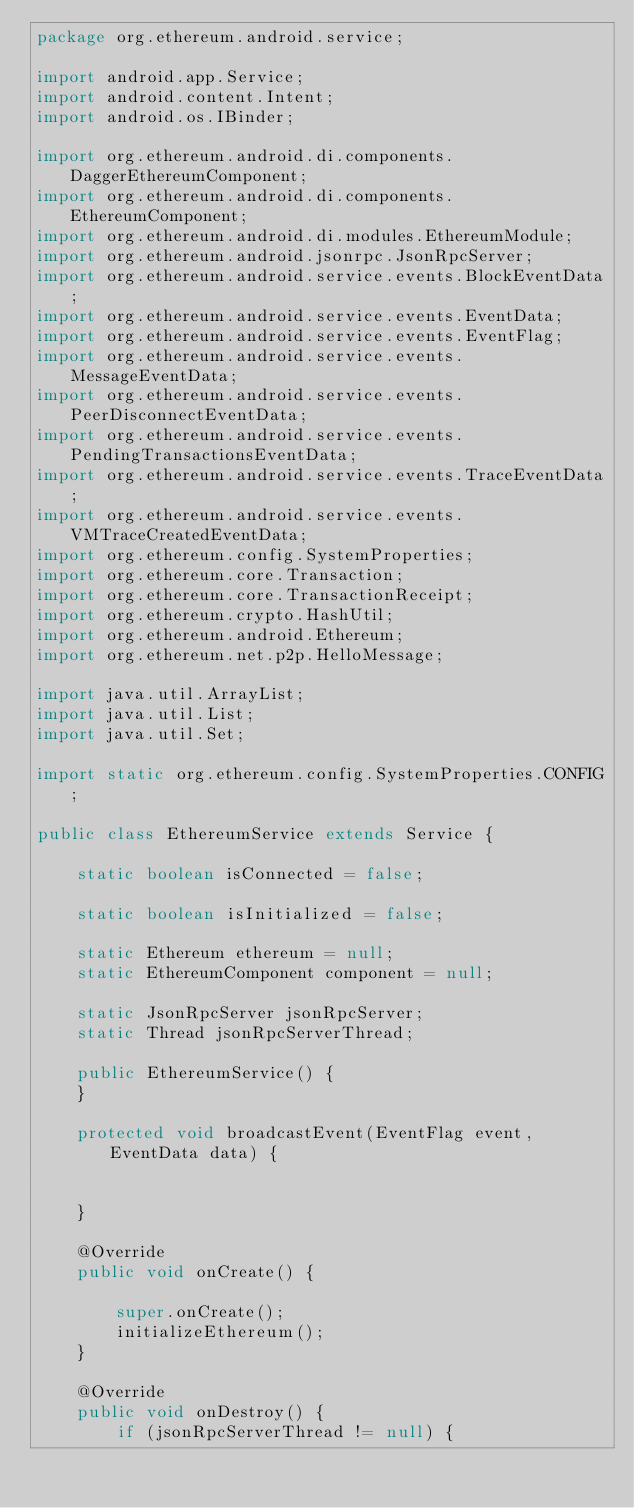Convert code to text. <code><loc_0><loc_0><loc_500><loc_500><_Java_>package org.ethereum.android.service;

import android.app.Service;
import android.content.Intent;
import android.os.IBinder;

import org.ethereum.android.di.components.DaggerEthereumComponent;
import org.ethereum.android.di.components.EthereumComponent;
import org.ethereum.android.di.modules.EthereumModule;
import org.ethereum.android.jsonrpc.JsonRpcServer;
import org.ethereum.android.service.events.BlockEventData;
import org.ethereum.android.service.events.EventData;
import org.ethereum.android.service.events.EventFlag;
import org.ethereum.android.service.events.MessageEventData;
import org.ethereum.android.service.events.PeerDisconnectEventData;
import org.ethereum.android.service.events.PendingTransactionsEventData;
import org.ethereum.android.service.events.TraceEventData;
import org.ethereum.android.service.events.VMTraceCreatedEventData;
import org.ethereum.config.SystemProperties;
import org.ethereum.core.Transaction;
import org.ethereum.core.TransactionReceipt;
import org.ethereum.crypto.HashUtil;
import org.ethereum.android.Ethereum;
import org.ethereum.net.p2p.HelloMessage;

import java.util.ArrayList;
import java.util.List;
import java.util.Set;

import static org.ethereum.config.SystemProperties.CONFIG;

public class EthereumService extends Service {

    static boolean isConnected = false;

    static boolean isInitialized = false;

    static Ethereum ethereum = null;
    static EthereumComponent component = null;

    static JsonRpcServer jsonRpcServer;
    static Thread jsonRpcServerThread;

    public EthereumService() {
    }

    protected void broadcastEvent(EventFlag event, EventData data) {


    }

    @Override
    public void onCreate() {

        super.onCreate();
        initializeEthereum();
    }

    @Override
    public void onDestroy() {
        if (jsonRpcServerThread != null) {</code> 